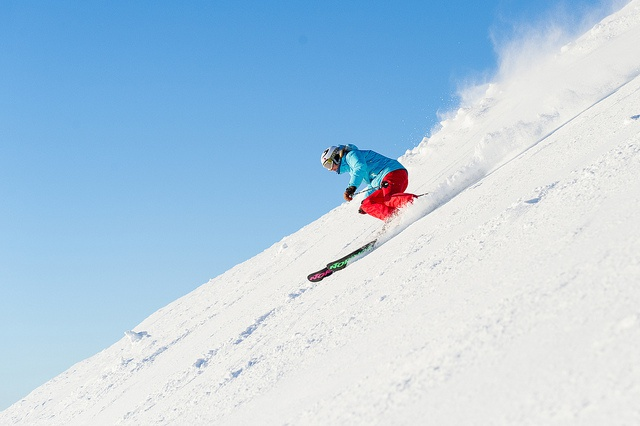Describe the objects in this image and their specific colors. I can see people in lightblue, teal, brown, red, and lightgray tones and skis in lightblue, black, darkgray, gray, and lightgray tones in this image. 